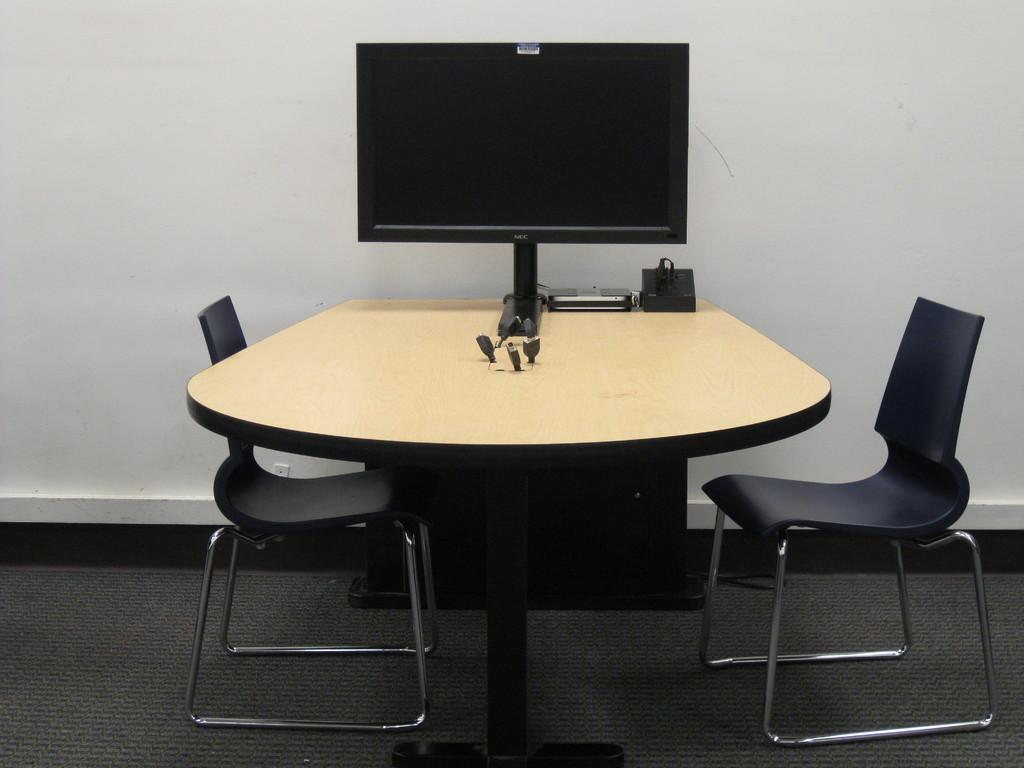What piece of furniture is present in the image? There is a table in the image. What electronic device is on the table? There is a computer on the table. What other items are on the table? There are other devices on the table. What type of seating is near the table? There are chairs near the table. What can be seen in the background of the image? There is a wall in the background of the image. Reasoning: Let' Let's think step by step in order to produce the conversation. We start by identifying the main piece of furniture in the image, which is the table. Then, we describe the primary electronic device on the table, which is the computer. Next, we mention other items on the table, followed by the type of seating near the table. Finally, we describe the background of the image, which includes a wall. Absurd Question/Answer: What type of needle is being used to step on the ice in the image? There is no needle or ice present in the image; it features a table with a computer and other devices. 